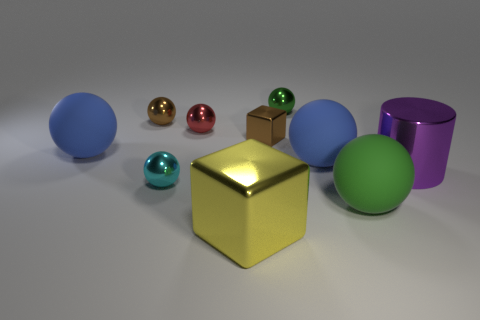Which objects have textures that distinguish them from the others? Observing the objects, it appears the blue and green spheres have a matte, rubber-like texture, differentiating them from the other objects which have a shiny, metallic or smooth surface. 